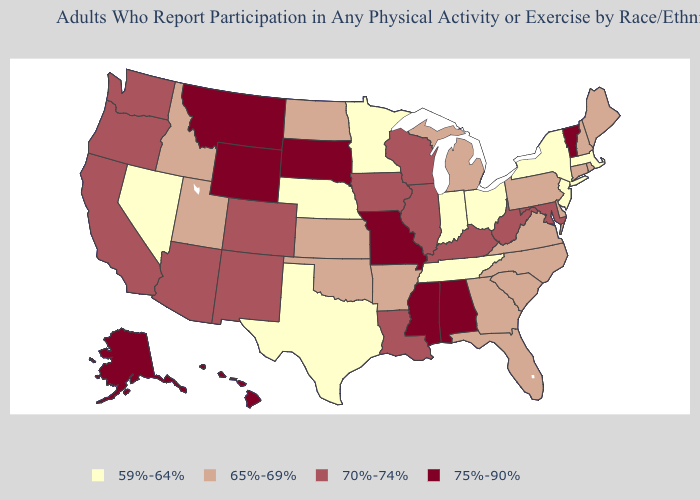Among the states that border West Virginia , does Kentucky have the lowest value?
Quick response, please. No. Name the states that have a value in the range 59%-64%?
Answer briefly. Indiana, Massachusetts, Minnesota, Nebraska, Nevada, New Jersey, New York, Ohio, Tennessee, Texas. Name the states that have a value in the range 75%-90%?
Keep it brief. Alabama, Alaska, Hawaii, Mississippi, Missouri, Montana, South Dakota, Vermont, Wyoming. Does the map have missing data?
Concise answer only. No. Which states have the highest value in the USA?
Write a very short answer. Alabama, Alaska, Hawaii, Mississippi, Missouri, Montana, South Dakota, Vermont, Wyoming. Does the first symbol in the legend represent the smallest category?
Quick response, please. Yes. What is the value of North Carolina?
Give a very brief answer. 65%-69%. Name the states that have a value in the range 59%-64%?
Quick response, please. Indiana, Massachusetts, Minnesota, Nebraska, Nevada, New Jersey, New York, Ohio, Tennessee, Texas. Among the states that border Indiana , which have the lowest value?
Quick response, please. Ohio. Name the states that have a value in the range 75%-90%?
Concise answer only. Alabama, Alaska, Hawaii, Mississippi, Missouri, Montana, South Dakota, Vermont, Wyoming. What is the value of New Mexico?
Short answer required. 70%-74%. Does the first symbol in the legend represent the smallest category?
Write a very short answer. Yes. Name the states that have a value in the range 75%-90%?
Answer briefly. Alabama, Alaska, Hawaii, Mississippi, Missouri, Montana, South Dakota, Vermont, Wyoming. Name the states that have a value in the range 75%-90%?
Give a very brief answer. Alabama, Alaska, Hawaii, Mississippi, Missouri, Montana, South Dakota, Vermont, Wyoming. What is the value of Alabama?
Be succinct. 75%-90%. 